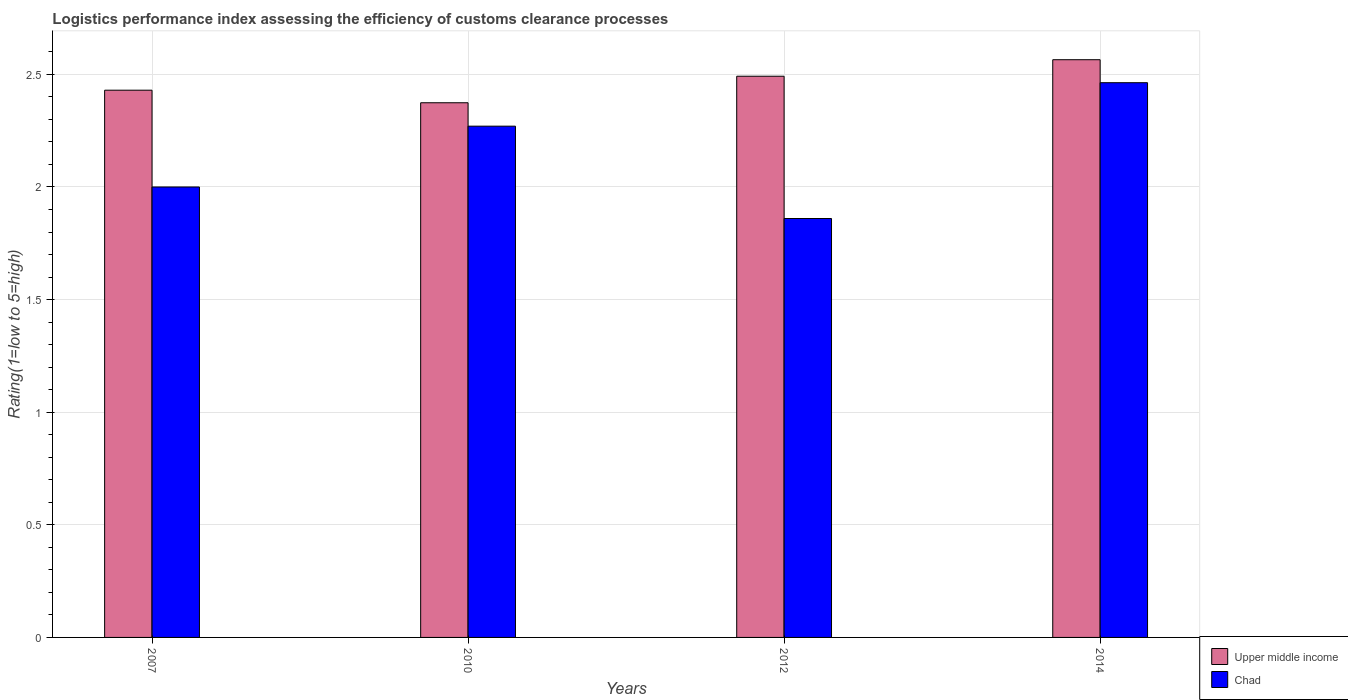How many groups of bars are there?
Offer a terse response. 4. Are the number of bars on each tick of the X-axis equal?
Ensure brevity in your answer.  Yes. In how many cases, is the number of bars for a given year not equal to the number of legend labels?
Provide a short and direct response. 0. What is the Logistic performance index in Chad in 2014?
Your answer should be very brief. 2.46. Across all years, what is the maximum Logistic performance index in Chad?
Keep it short and to the point. 2.46. Across all years, what is the minimum Logistic performance index in Chad?
Offer a very short reply. 1.86. In which year was the Logistic performance index in Chad maximum?
Provide a short and direct response. 2014. What is the total Logistic performance index in Chad in the graph?
Offer a terse response. 8.59. What is the difference between the Logistic performance index in Chad in 2012 and that in 2014?
Your answer should be very brief. -0.6. What is the difference between the Logistic performance index in Upper middle income in 2010 and the Logistic performance index in Chad in 2014?
Provide a short and direct response. -0.09. What is the average Logistic performance index in Upper middle income per year?
Offer a terse response. 2.47. In the year 2010, what is the difference between the Logistic performance index in Chad and Logistic performance index in Upper middle income?
Give a very brief answer. -0.1. In how many years, is the Logistic performance index in Chad greater than 1.7?
Your response must be concise. 4. What is the ratio of the Logistic performance index in Upper middle income in 2010 to that in 2012?
Provide a succinct answer. 0.95. Is the difference between the Logistic performance index in Chad in 2007 and 2010 greater than the difference between the Logistic performance index in Upper middle income in 2007 and 2010?
Give a very brief answer. No. What is the difference between the highest and the second highest Logistic performance index in Chad?
Give a very brief answer. 0.19. What is the difference between the highest and the lowest Logistic performance index in Upper middle income?
Keep it short and to the point. 0.19. Is the sum of the Logistic performance index in Chad in 2007 and 2014 greater than the maximum Logistic performance index in Upper middle income across all years?
Keep it short and to the point. Yes. What does the 1st bar from the left in 2007 represents?
Give a very brief answer. Upper middle income. What does the 2nd bar from the right in 2014 represents?
Offer a very short reply. Upper middle income. How many bars are there?
Your answer should be compact. 8. How many years are there in the graph?
Offer a very short reply. 4. What is the difference between two consecutive major ticks on the Y-axis?
Ensure brevity in your answer.  0.5. Are the values on the major ticks of Y-axis written in scientific E-notation?
Your response must be concise. No. Does the graph contain grids?
Provide a short and direct response. Yes. Where does the legend appear in the graph?
Your response must be concise. Bottom right. How are the legend labels stacked?
Keep it short and to the point. Vertical. What is the title of the graph?
Ensure brevity in your answer.  Logistics performance index assessing the efficiency of customs clearance processes. Does "Northern Mariana Islands" appear as one of the legend labels in the graph?
Your response must be concise. No. What is the label or title of the X-axis?
Provide a short and direct response. Years. What is the label or title of the Y-axis?
Your answer should be very brief. Rating(1=low to 5=high). What is the Rating(1=low to 5=high) of Upper middle income in 2007?
Ensure brevity in your answer.  2.43. What is the Rating(1=low to 5=high) of Chad in 2007?
Offer a very short reply. 2. What is the Rating(1=low to 5=high) of Upper middle income in 2010?
Your response must be concise. 2.37. What is the Rating(1=low to 5=high) in Chad in 2010?
Make the answer very short. 2.27. What is the Rating(1=low to 5=high) in Upper middle income in 2012?
Your response must be concise. 2.49. What is the Rating(1=low to 5=high) in Chad in 2012?
Provide a succinct answer. 1.86. What is the Rating(1=low to 5=high) in Upper middle income in 2014?
Your answer should be compact. 2.57. What is the Rating(1=low to 5=high) in Chad in 2014?
Offer a terse response. 2.46. Across all years, what is the maximum Rating(1=low to 5=high) of Upper middle income?
Your response must be concise. 2.57. Across all years, what is the maximum Rating(1=low to 5=high) in Chad?
Keep it short and to the point. 2.46. Across all years, what is the minimum Rating(1=low to 5=high) in Upper middle income?
Ensure brevity in your answer.  2.37. Across all years, what is the minimum Rating(1=low to 5=high) in Chad?
Your response must be concise. 1.86. What is the total Rating(1=low to 5=high) in Upper middle income in the graph?
Make the answer very short. 9.86. What is the total Rating(1=low to 5=high) of Chad in the graph?
Make the answer very short. 8.59. What is the difference between the Rating(1=low to 5=high) in Upper middle income in 2007 and that in 2010?
Your answer should be very brief. 0.06. What is the difference between the Rating(1=low to 5=high) of Chad in 2007 and that in 2010?
Keep it short and to the point. -0.27. What is the difference between the Rating(1=low to 5=high) of Upper middle income in 2007 and that in 2012?
Keep it short and to the point. -0.06. What is the difference between the Rating(1=low to 5=high) of Chad in 2007 and that in 2012?
Give a very brief answer. 0.14. What is the difference between the Rating(1=low to 5=high) of Upper middle income in 2007 and that in 2014?
Make the answer very short. -0.14. What is the difference between the Rating(1=low to 5=high) of Chad in 2007 and that in 2014?
Offer a very short reply. -0.46. What is the difference between the Rating(1=low to 5=high) of Upper middle income in 2010 and that in 2012?
Offer a terse response. -0.12. What is the difference between the Rating(1=low to 5=high) in Chad in 2010 and that in 2012?
Ensure brevity in your answer.  0.41. What is the difference between the Rating(1=low to 5=high) in Upper middle income in 2010 and that in 2014?
Keep it short and to the point. -0.19. What is the difference between the Rating(1=low to 5=high) of Chad in 2010 and that in 2014?
Provide a short and direct response. -0.19. What is the difference between the Rating(1=low to 5=high) of Upper middle income in 2012 and that in 2014?
Ensure brevity in your answer.  -0.07. What is the difference between the Rating(1=low to 5=high) in Chad in 2012 and that in 2014?
Your answer should be compact. -0.6. What is the difference between the Rating(1=low to 5=high) of Upper middle income in 2007 and the Rating(1=low to 5=high) of Chad in 2010?
Make the answer very short. 0.16. What is the difference between the Rating(1=low to 5=high) in Upper middle income in 2007 and the Rating(1=low to 5=high) in Chad in 2012?
Your answer should be very brief. 0.57. What is the difference between the Rating(1=low to 5=high) in Upper middle income in 2007 and the Rating(1=low to 5=high) in Chad in 2014?
Your answer should be very brief. -0.03. What is the difference between the Rating(1=low to 5=high) of Upper middle income in 2010 and the Rating(1=low to 5=high) of Chad in 2012?
Your response must be concise. 0.51. What is the difference between the Rating(1=low to 5=high) in Upper middle income in 2010 and the Rating(1=low to 5=high) in Chad in 2014?
Keep it short and to the point. -0.09. What is the difference between the Rating(1=low to 5=high) in Upper middle income in 2012 and the Rating(1=low to 5=high) in Chad in 2014?
Give a very brief answer. 0.03. What is the average Rating(1=low to 5=high) of Upper middle income per year?
Your response must be concise. 2.47. What is the average Rating(1=low to 5=high) of Chad per year?
Make the answer very short. 2.15. In the year 2007, what is the difference between the Rating(1=low to 5=high) of Upper middle income and Rating(1=low to 5=high) of Chad?
Ensure brevity in your answer.  0.43. In the year 2010, what is the difference between the Rating(1=low to 5=high) of Upper middle income and Rating(1=low to 5=high) of Chad?
Give a very brief answer. 0.1. In the year 2012, what is the difference between the Rating(1=low to 5=high) in Upper middle income and Rating(1=low to 5=high) in Chad?
Make the answer very short. 0.63. In the year 2014, what is the difference between the Rating(1=low to 5=high) in Upper middle income and Rating(1=low to 5=high) in Chad?
Ensure brevity in your answer.  0.1. What is the ratio of the Rating(1=low to 5=high) of Upper middle income in 2007 to that in 2010?
Offer a terse response. 1.02. What is the ratio of the Rating(1=low to 5=high) of Chad in 2007 to that in 2010?
Provide a succinct answer. 0.88. What is the ratio of the Rating(1=low to 5=high) of Upper middle income in 2007 to that in 2012?
Offer a very short reply. 0.98. What is the ratio of the Rating(1=low to 5=high) in Chad in 2007 to that in 2012?
Ensure brevity in your answer.  1.08. What is the ratio of the Rating(1=low to 5=high) in Upper middle income in 2007 to that in 2014?
Offer a very short reply. 0.95. What is the ratio of the Rating(1=low to 5=high) in Chad in 2007 to that in 2014?
Make the answer very short. 0.81. What is the ratio of the Rating(1=low to 5=high) of Upper middle income in 2010 to that in 2012?
Provide a succinct answer. 0.95. What is the ratio of the Rating(1=low to 5=high) in Chad in 2010 to that in 2012?
Keep it short and to the point. 1.22. What is the ratio of the Rating(1=low to 5=high) of Upper middle income in 2010 to that in 2014?
Offer a terse response. 0.93. What is the ratio of the Rating(1=low to 5=high) in Chad in 2010 to that in 2014?
Offer a terse response. 0.92. What is the ratio of the Rating(1=low to 5=high) of Upper middle income in 2012 to that in 2014?
Offer a very short reply. 0.97. What is the ratio of the Rating(1=low to 5=high) of Chad in 2012 to that in 2014?
Offer a terse response. 0.76. What is the difference between the highest and the second highest Rating(1=low to 5=high) in Upper middle income?
Give a very brief answer. 0.07. What is the difference between the highest and the second highest Rating(1=low to 5=high) of Chad?
Keep it short and to the point. 0.19. What is the difference between the highest and the lowest Rating(1=low to 5=high) in Upper middle income?
Provide a short and direct response. 0.19. What is the difference between the highest and the lowest Rating(1=low to 5=high) of Chad?
Make the answer very short. 0.6. 